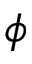Convert formula to latex. <formula><loc_0><loc_0><loc_500><loc_500>\phi</formula> 